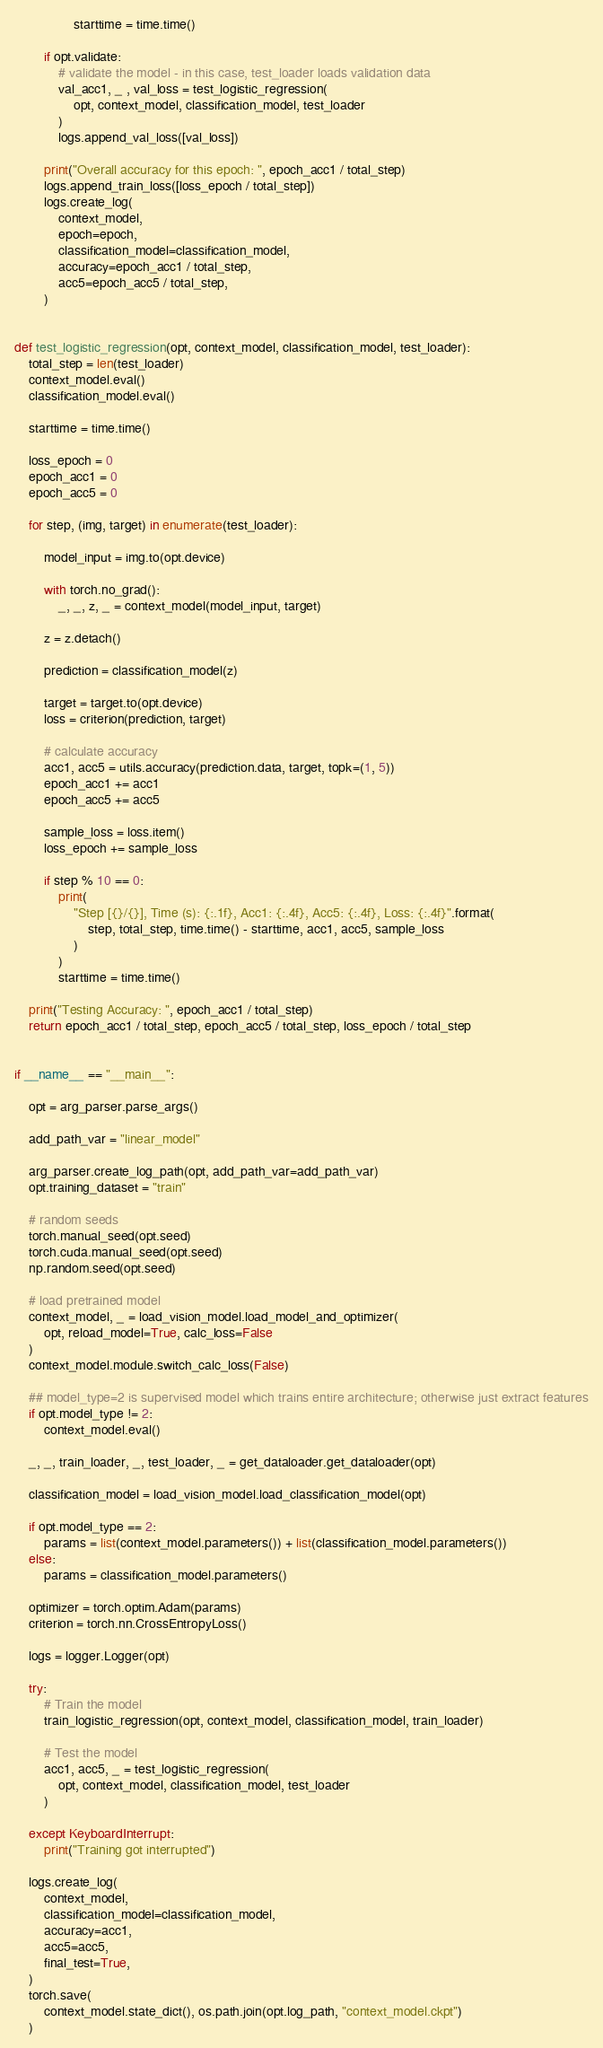Convert code to text. <code><loc_0><loc_0><loc_500><loc_500><_Python_>                starttime = time.time()

        if opt.validate:
            # validate the model - in this case, test_loader loads validation data
            val_acc1, _ , val_loss = test_logistic_regression(
                opt, context_model, classification_model, test_loader
            )
            logs.append_val_loss([val_loss])

        print("Overall accuracy for this epoch: ", epoch_acc1 / total_step)
        logs.append_train_loss([loss_epoch / total_step])
        logs.create_log(
            context_model,
            epoch=epoch,
            classification_model=classification_model,
            accuracy=epoch_acc1 / total_step,
            acc5=epoch_acc5 / total_step,
        )


def test_logistic_regression(opt, context_model, classification_model, test_loader):
    total_step = len(test_loader)
    context_model.eval()
    classification_model.eval()

    starttime = time.time()

    loss_epoch = 0
    epoch_acc1 = 0
    epoch_acc5 = 0

    for step, (img, target) in enumerate(test_loader):

        model_input = img.to(opt.device)

        with torch.no_grad():
            _, _, z, _ = context_model(model_input, target)

        z = z.detach()

        prediction = classification_model(z)

        target = target.to(opt.device)
        loss = criterion(prediction, target)

        # calculate accuracy
        acc1, acc5 = utils.accuracy(prediction.data, target, topk=(1, 5))
        epoch_acc1 += acc1
        epoch_acc5 += acc5

        sample_loss = loss.item()
        loss_epoch += sample_loss

        if step % 10 == 0:
            print(
                "Step [{}/{}], Time (s): {:.1f}, Acc1: {:.4f}, Acc5: {:.4f}, Loss: {:.4f}".format(
                    step, total_step, time.time() - starttime, acc1, acc5, sample_loss
                )
            )
            starttime = time.time()

    print("Testing Accuracy: ", epoch_acc1 / total_step)
    return epoch_acc1 / total_step, epoch_acc5 / total_step, loss_epoch / total_step


if __name__ == "__main__":

    opt = arg_parser.parse_args()

    add_path_var = "linear_model"

    arg_parser.create_log_path(opt, add_path_var=add_path_var)
    opt.training_dataset = "train"

    # random seeds
    torch.manual_seed(opt.seed)
    torch.cuda.manual_seed(opt.seed)
    np.random.seed(opt.seed)

    # load pretrained model
    context_model, _ = load_vision_model.load_model_and_optimizer(
        opt, reload_model=True, calc_loss=False
    )
    context_model.module.switch_calc_loss(False)

    ## model_type=2 is supervised model which trains entire architecture; otherwise just extract features
    if opt.model_type != 2:
        context_model.eval()

    _, _, train_loader, _, test_loader, _ = get_dataloader.get_dataloader(opt)

    classification_model = load_vision_model.load_classification_model(opt)

    if opt.model_type == 2:
        params = list(context_model.parameters()) + list(classification_model.parameters())
    else:
        params = classification_model.parameters()

    optimizer = torch.optim.Adam(params)
    criterion = torch.nn.CrossEntropyLoss()

    logs = logger.Logger(opt)

    try:
        # Train the model
        train_logistic_regression(opt, context_model, classification_model, train_loader)

        # Test the model
        acc1, acc5, _ = test_logistic_regression(
            opt, context_model, classification_model, test_loader
        )

    except KeyboardInterrupt:
        print("Training got interrupted")

    logs.create_log(
        context_model,
        classification_model=classification_model,
        accuracy=acc1,
        acc5=acc5,
        final_test=True,
    )
    torch.save(
        context_model.state_dict(), os.path.join(opt.log_path, "context_model.ckpt")
    )
</code> 